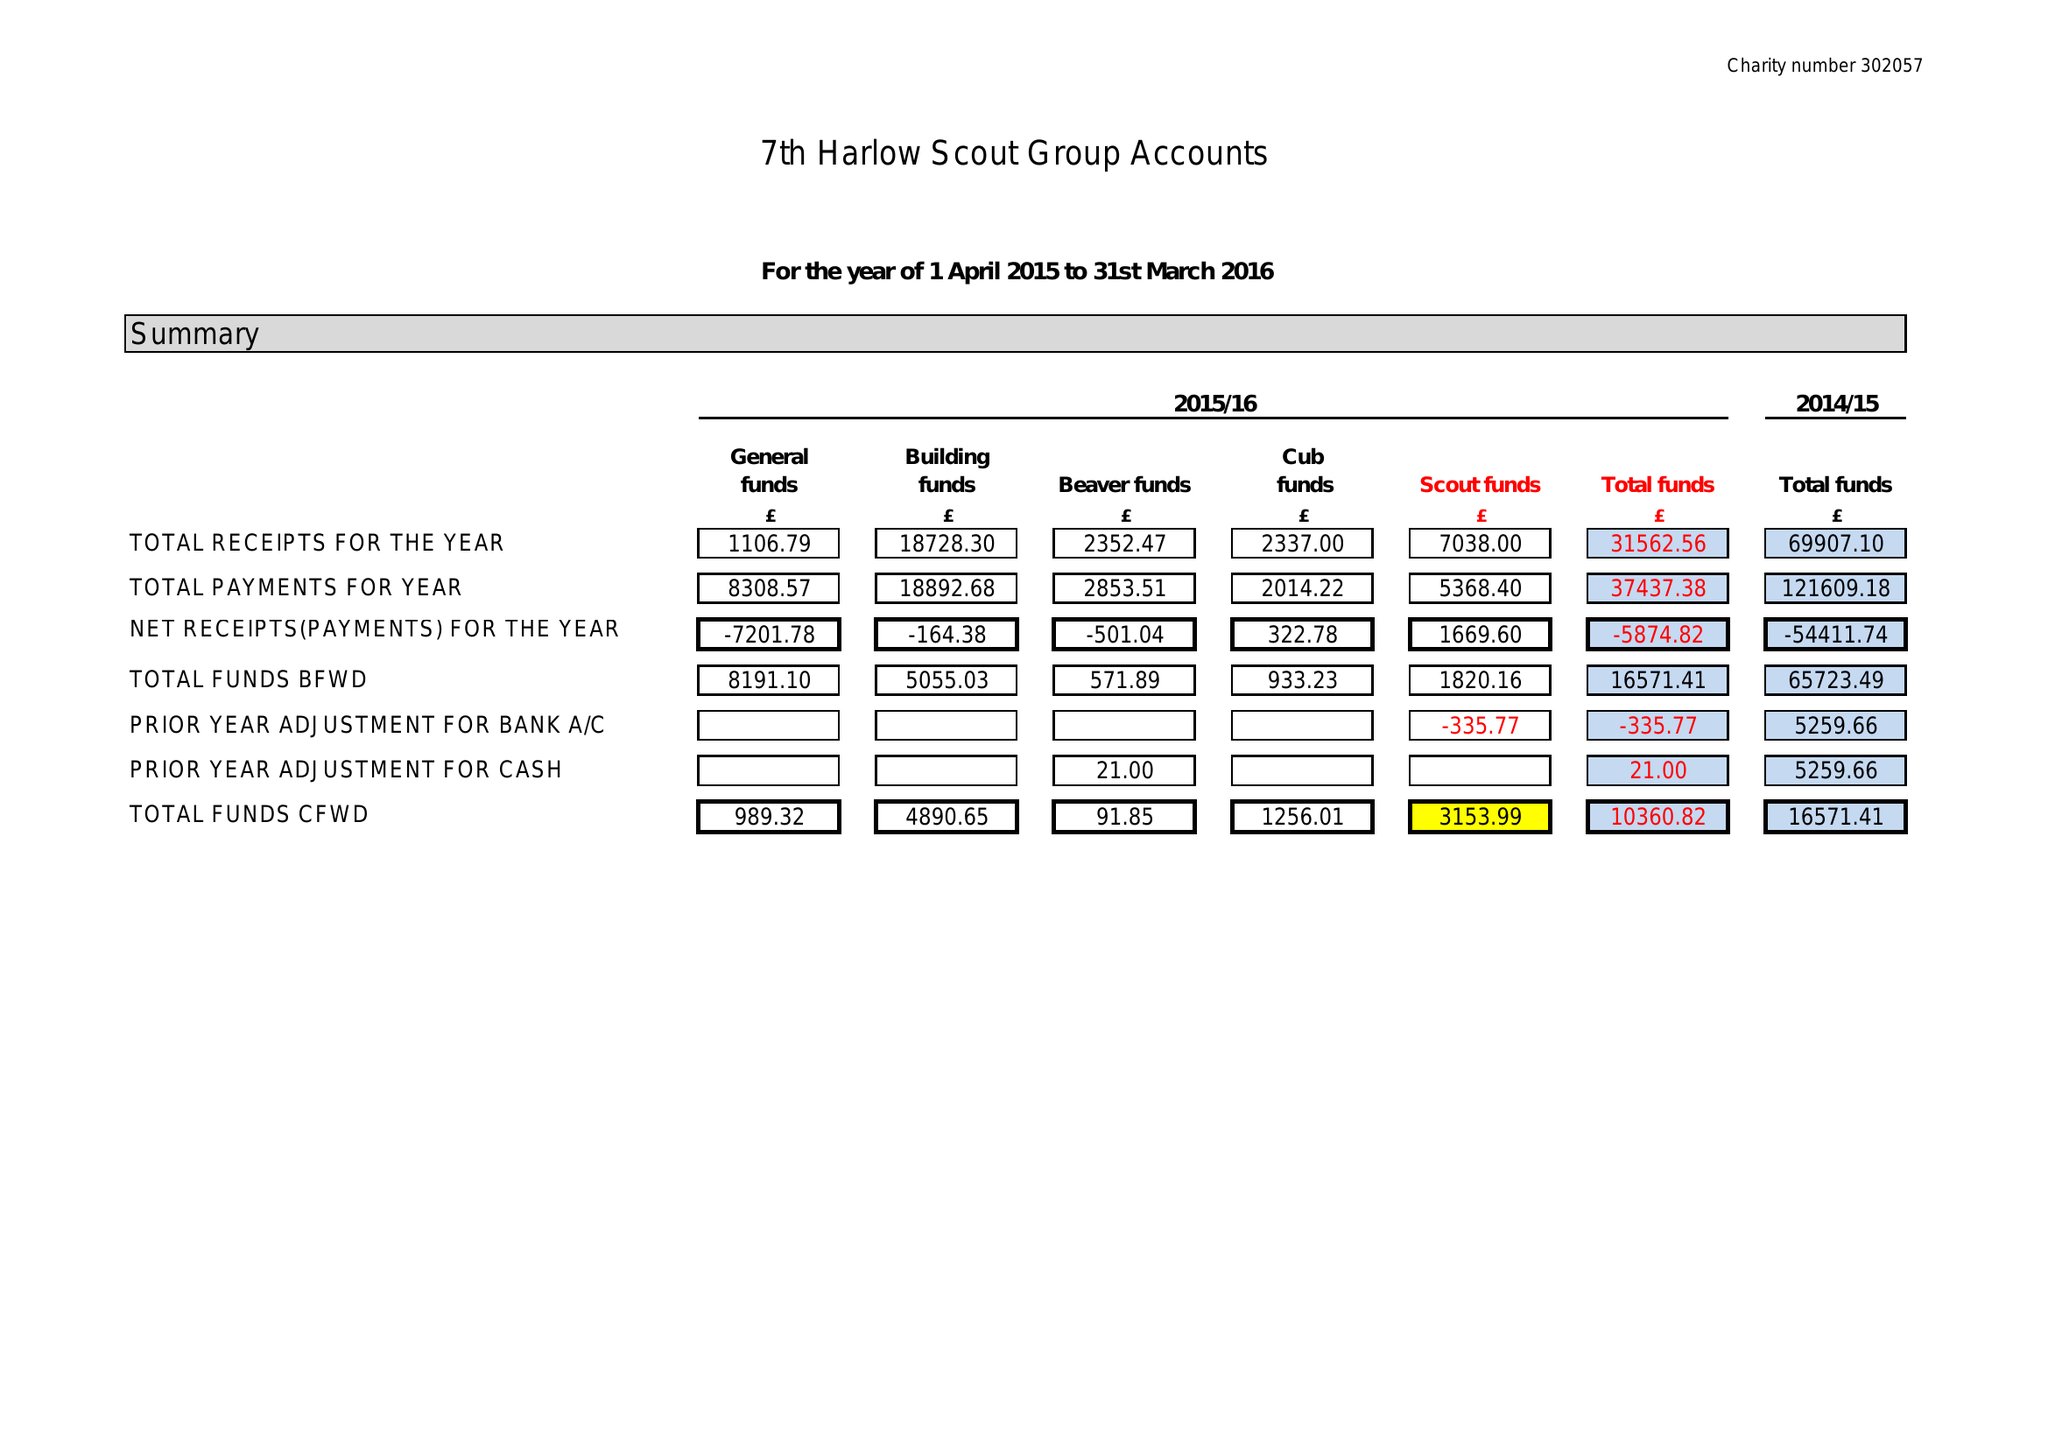What is the value for the address__postcode?
Answer the question using a single word or phrase. CM20 1PY 